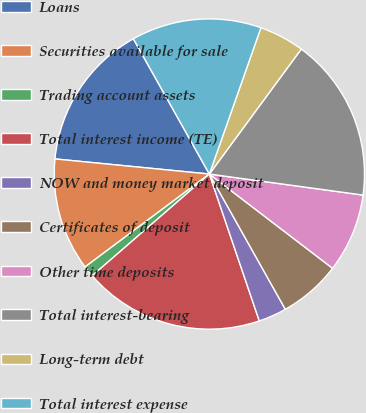<chart> <loc_0><loc_0><loc_500><loc_500><pie_chart><fcel>Loans<fcel>Securities available for sale<fcel>Trading account assets<fcel>Total interest income (TE)<fcel>NOW and money market deposit<fcel>Certificates of deposit<fcel>Other time deposits<fcel>Total interest-bearing<fcel>Long-term debt<fcel>Total interest expense<nl><fcel>15.3%<fcel>11.77%<fcel>1.16%<fcel>18.84%<fcel>2.93%<fcel>6.46%<fcel>8.23%<fcel>17.07%<fcel>4.7%<fcel>13.54%<nl></chart> 